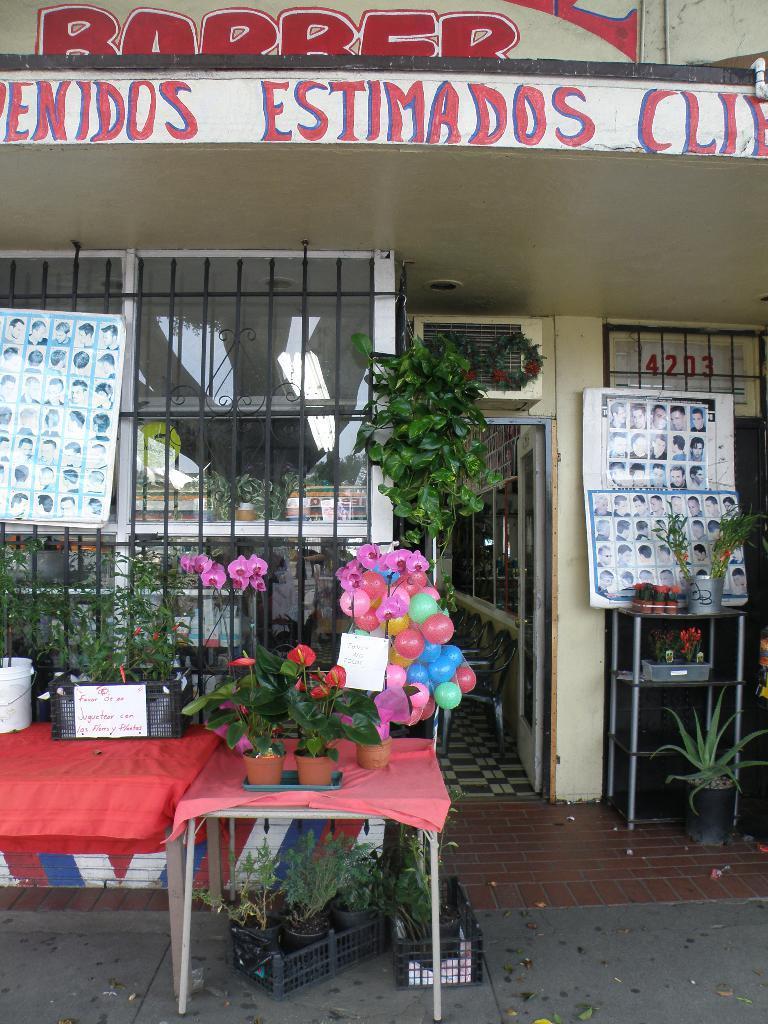Describe this image in one or two sentences. The picture is taken outside the room and there are tables , on one table there are three pots with plants and another table with plants and behind them there is a window with glass and grills and there is a door and in the room there are chairs and at the right corner there is another table where some plants on it and some photos are placed on the board and on the other table there is another plant and on the building there is some text written in red colour. 